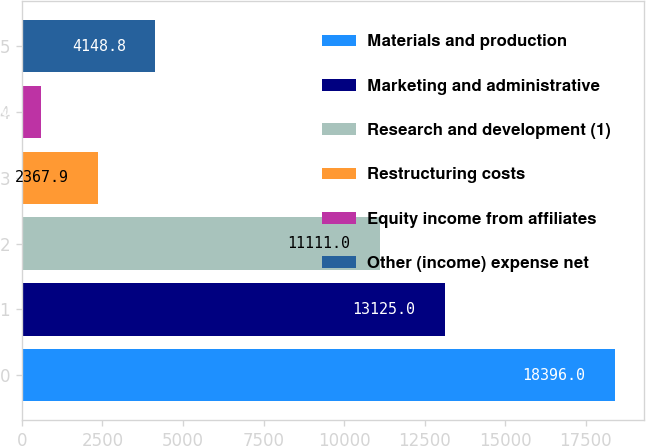Convert chart. <chart><loc_0><loc_0><loc_500><loc_500><bar_chart><fcel>Materials and production<fcel>Marketing and administrative<fcel>Research and development (1)<fcel>Restructuring costs<fcel>Equity income from affiliates<fcel>Other (income) expense net<nl><fcel>18396<fcel>13125<fcel>11111<fcel>2367.9<fcel>587<fcel>4148.8<nl></chart> 